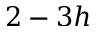<formula> <loc_0><loc_0><loc_500><loc_500>2 - 3 h</formula> 